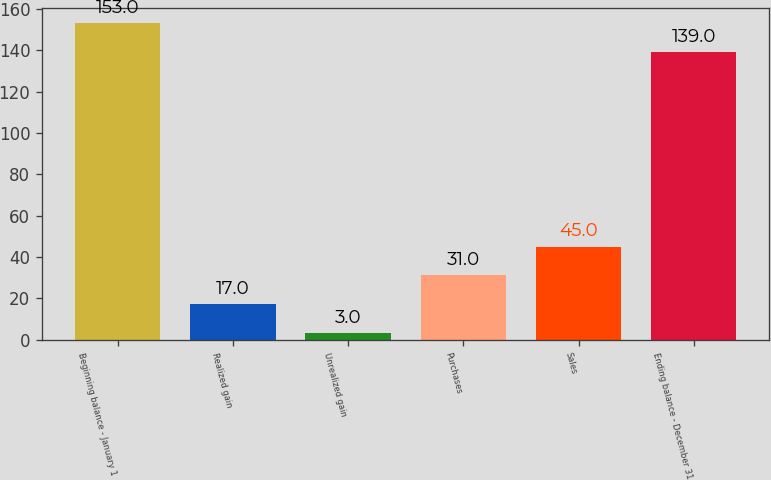Convert chart. <chart><loc_0><loc_0><loc_500><loc_500><bar_chart><fcel>Beginning balance - January 1<fcel>Realized gain<fcel>Unrealized gain<fcel>Purchases<fcel>Sales<fcel>Ending balance - December 31<nl><fcel>153<fcel>17<fcel>3<fcel>31<fcel>45<fcel>139<nl></chart> 